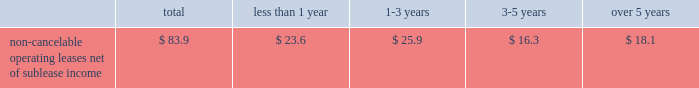Building .
The construction of the building was completed in december 2003 .
Due to lower than expected financing and construction costs , the final lease balance was lowered to $ 103.0 million .
As part of the agreement , we entered into a five-year lease that began upon the completion of the building .
At the end of the lease term , we can purchase the building for the lease balance , remarket or relinquish the building .
If we choose to remarket or are required to do so upon relinquishing the building , we are bound to arrange the sale of the building to an unrelated party and will be required to pay the lessor any shortfall between the net remarketing proceeds and the lease balance , up to the maximum recourse amount of $ 90.8 million ( 201cresidual value guarantee 201d ) .
See note 14 in our notes to consolidated financial statements for further information .
In august 1999 , we entered into a five-year lease agreement for our other two office buildings that currently serve as our corporate headquarters in san jose , california .
Under the agreement , we have the option to purchase the buildings at any time during the lease term for the lease balance , which is approximately $ 142.5 million .
We are in the process of evaluating alternative financing methods at expiration of the lease in fiscal 2004 and believe that several suitable financing options will be available to us .
At the end of the lease term , we can purchase the buildings for the lease balance , remarket or relinquish the buildings .
If we choose to remarket or are required to do so upon relinquishing the buildings , we are bound to arrange the sale of the buildings to an unrelated party and will be required to pay the lessor any shortfall between the net remarketing proceeds and the lease balance , up to the maximum recourse amount of $ 132.6 million ( 201cresidual value guarantee 201d ) .
For further information , see note 14 in our notes to consolidated financial statements .
The two lease agreements discussed above are subject to standard financial covenants .
The agreements limit the amount of indebtedness we can incur .
A leverage covenant requires us to keep our debt to ebitda ratio less than 2.5:1.0 .
As of november 28 , 2003 , our debt to ebitda ratio was 0.53:1.0 , well within the limit .
We also have a liquidity covenant which requires us to maintain a quick ratio equal to or greater than 1.0 .
As of november 28 , 2003 , our quick ratio was 2.2 , well above the minimum .
We expect to remain within compliance in the next 12 months .
We are comfortable with these limitations and believe they will not impact our cash or credit in the coming year or restrict our ability to execute our business plan .
The table summarizes our contractual commitments as of november 28 , 2003 : less than over total 1 year 1 2013 3 years 3-5 years 5 years non-cancelable operating leases , net of sublease income ................ .
$ 83.9 $ 23.6 $ 25.9 $ 16.3 $ 18.1 indemnifications in the normal course of business , we provide indemnifications of varying scope to customers against claims of intellectual property infringement made by third parties arising from the use of our products .
Historically , costs related to these indemnification provisions have not been significant and we are unable to estimate the maximum potential impact of these indemnification provisions on our future results of operations .
We have commitments to make certain milestone and/or retention payments typically entered into in conjunction with various acquisitions , for which we have made accruals in our consolidated financial statements .
In connection with our purchases of technology assets during fiscal 2003 , we entered into employee retention agreements totaling $ 2.2 million .
We are required to make payments upon satisfaction of certain conditions in the agreements .
As permitted under delaware law , we have agreements whereby we indemnify our officers and directors for certain events or occurrences while the officer or director is , or was serving , at our request in such capacity .
The indemnification period covers all pertinent events and occurrences during the officer 2019s or director 2019s lifetime .
The maximum potential amount of future payments we could be required to make under these indemnification agreements is unlimited ; however , we have director and officer insurance coverage that limits our exposure and enables us to recover a portion of any future amounts paid .
We believe the estimated fair value of these indemnification agreements in excess of applicable insurance coverage is minimal. .
Building .
The construction of the building was completed in december 2003 .
Due to lower than expected financing and construction costs , the final lease balance was lowered to $ 103.0 million .
As part of the agreement , we entered into a five-year lease that began upon the completion of the building .
At the end of the lease term , we can purchase the building for the lease balance , remarket or relinquish the building .
If we choose to remarket or are required to do so upon relinquishing the building , we are bound to arrange the sale of the building to an unrelated party and will be required to pay the lessor any shortfall between the net remarketing proceeds and the lease balance , up to the maximum recourse amount of $ 90.8 million ( 201cresidual value guarantee 201d ) .
See note 14 in our notes to consolidated financial statements for further information .
In august 1999 , we entered into a five-year lease agreement for our other two office buildings that currently serve as our corporate headquarters in san jose , california .
Under the agreement , we have the option to purchase the buildings at any time during the lease term for the lease balance , which is approximately $ 142.5 million .
We are in the process of evaluating alternative financing methods at expiration of the lease in fiscal 2004 and believe that several suitable financing options will be available to us .
At the end of the lease term , we can purchase the buildings for the lease balance , remarket or relinquish the buildings .
If we choose to remarket or are required to do so upon relinquishing the buildings , we are bound to arrange the sale of the buildings to an unrelated party and will be required to pay the lessor any shortfall between the net remarketing proceeds and the lease balance , up to the maximum recourse amount of $ 132.6 million ( 201cresidual value guarantee 201d ) .
For further information , see note 14 in our notes to consolidated financial statements .
The two lease agreements discussed above are subject to standard financial covenants .
The agreements limit the amount of indebtedness we can incur .
A leverage covenant requires us to keep our debt to ebitda ratio less than 2.5:1.0 .
As of november 28 , 2003 , our debt to ebitda ratio was 0.53:1.0 , well within the limit .
We also have a liquidity covenant which requires us to maintain a quick ratio equal to or greater than 1.0 .
As of november 28 , 2003 , our quick ratio was 2.2 , well above the minimum .
We expect to remain within compliance in the next 12 months .
We are comfortable with these limitations and believe they will not impact our cash or credit in the coming year or restrict our ability to execute our business plan .
The following table summarizes our contractual commitments as of november 28 , 2003 : less than over total 1 year 1 2013 3 years 3-5 years 5 years non-cancelable operating leases , net of sublease income ................ .
$ 83.9 $ 23.6 $ 25.9 $ 16.3 $ 18.1 indemnifications in the normal course of business , we provide indemnifications of varying scope to customers against claims of intellectual property infringement made by third parties arising from the use of our products .
Historically , costs related to these indemnification provisions have not been significant and we are unable to estimate the maximum potential impact of these indemnification provisions on our future results of operations .
We have commitments to make certain milestone and/or retention payments typically entered into in conjunction with various acquisitions , for which we have made accruals in our consolidated financial statements .
In connection with our purchases of technology assets during fiscal 2003 , we entered into employee retention agreements totaling $ 2.2 million .
We are required to make payments upon satisfaction of certain conditions in the agreements .
As permitted under delaware law , we have agreements whereby we indemnify our officers and directors for certain events or occurrences while the officer or director is , or was serving , at our request in such capacity .
The indemnification period covers all pertinent events and occurrences during the officer 2019s or director 2019s lifetime .
The maximum potential amount of future payments we could be required to make under these indemnification agreements is unlimited ; however , we have director and officer insurance coverage that limits our exposure and enables us to recover a portion of any future amounts paid .
We believe the estimated fair value of these indemnification agreements in excess of applicable insurance coverage is minimal. .
What portion of the non-cancelable operating leases net of sublease income is due within the next 12 months? 
Computations: (23.6 / 83.9)
Answer: 0.28129. 